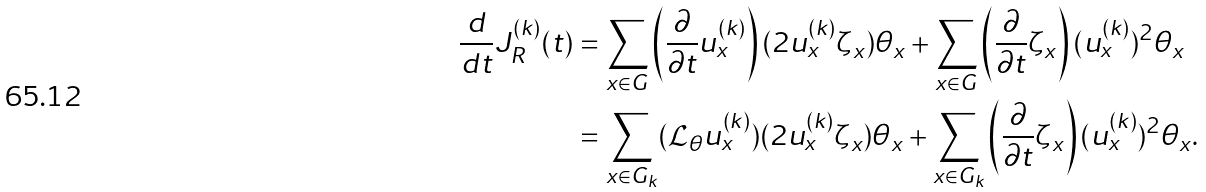<formula> <loc_0><loc_0><loc_500><loc_500>\frac { d } { d t } J ^ { ( k ) } _ { R } ( t ) & = \sum _ { x \in G } \left ( \frac { \partial } { \partial t } u ^ { ( k ) } _ { x } \right ) ( 2 u ^ { ( k ) } _ { x } \zeta _ { x } ) \theta _ { x } + \sum _ { x \in G } \left ( \frac { \partial } { \partial t } \zeta _ { x } \right ) ( u ^ { ( k ) } _ { x } ) ^ { 2 } \theta _ { x } \\ & = \sum _ { x \in G _ { k } } ( \mathcal { L } _ { \theta } u ^ { ( k ) } _ { x } ) ( 2 u ^ { ( k ) } _ { x } \zeta _ { x } ) \theta _ { x } + \sum _ { x \in G _ { k } } \left ( \frac { \partial } { \partial t } \zeta _ { x } \right ) ( u ^ { ( k ) } _ { x } ) ^ { 2 } \theta _ { x } .</formula> 